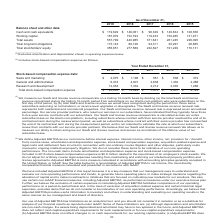From Alarmcom Holdings's financial document, What years does the table provide data for sales and marketing? The document contains multiple relevant values: 2019, 2018, 2017, 2016, 2015. From the document: "As of December 31, 2019 2018 2017 2016 2015 Balance sheet and other data: Cash and cash equivalents $ 119,629 $ 146,061 $ 96,329 As of December 31, 20..." Also, What was the amount of sales and marketing in 2018? According to the financial document, $1,196 (in thousands). The relevant text states: "ation expense data: Sales and marketing $ 2,075 $ 1,196 $ 561 $ 536 $ 372 General and administrative 6,474 4,901 2,638 1,430 2,486 Research and development..." Also, What was the amount of research and development in 2018? According to the financial document, 7,332 (in thousands). The relevant text states: "2,638 1,430 2,486 Research and development 12,054 7,332 4,214 2,035 1,266 Total stock-based compensation expense $ 20,603 $ 13,429 $ 7,413 $ 4,001 $ 4,124..." Also, How many years did the amount of general and administrative exceed $5,000 thousand? Based on the analysis, there are 1 instances. The counting process: 2019. Also, can you calculate: What was the change in the amount of research and development between 2018 and 2019? Based on the calculation: 12,054-7,332, the result is 4722 (in thousands). This is based on the information: "2,638 1,430 2,486 Research and development 12,054 7,332 4,214 2,035 1,266 Total stock-based compensation expense $ 20,603 $ 13,429 $ 7,413 $ 4,001 $ 4,124 4,901 2,638 1,430 2,486 Research and developm..." The key data points involved are: 12,054, 7,332. Also, can you calculate: What was the percentage change in the Total stock-based compensation expense between 2018 and 2019? To answer this question, I need to perform calculations using the financial data. The calculation is: (20,603-13,429)/13,429, which equals 53.42 (percentage). This is based on the information: "Total stock-based compensation expense $ 20,603 $ 13,429 $ 7,413 $ 4,001 $ 4,124 35 1,266 Total stock-based compensation expense $ 20,603 $ 13,429 $ 7,413 $ 4,001 $ 4,124..." The key data points involved are: 13,429, 20,603. 